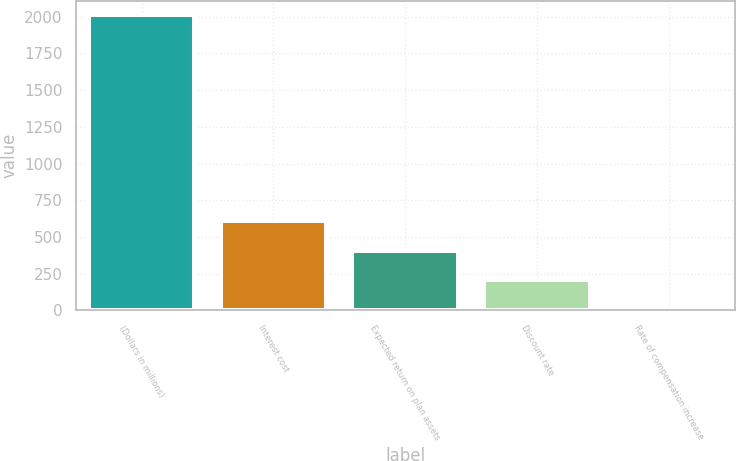Convert chart. <chart><loc_0><loc_0><loc_500><loc_500><bar_chart><fcel>(Dollars in millions)<fcel>Interest cost<fcel>Expected return on plan assets<fcel>Discount rate<fcel>Rate of compensation increase<nl><fcel>2009<fcel>605.93<fcel>405.49<fcel>205.05<fcel>4.61<nl></chart> 